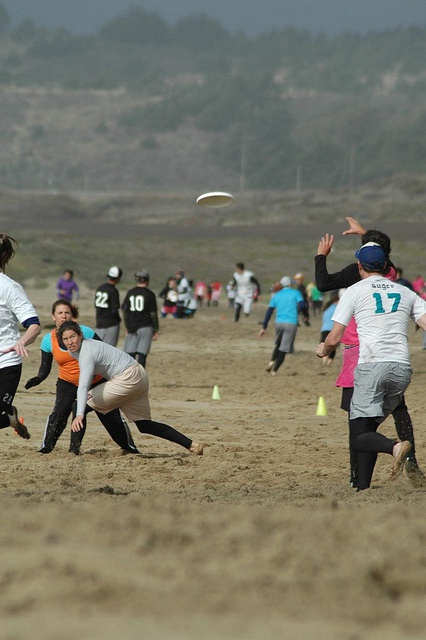Describe the objects in this image and their specific colors. I can see people in gray, lightgray, black, and darkgray tones, people in gray, black, darkgray, and maroon tones, people in gray, black, and brown tones, people in gray, black, red, and tan tones, and people in gray, lightgray, black, and darkgray tones in this image. 